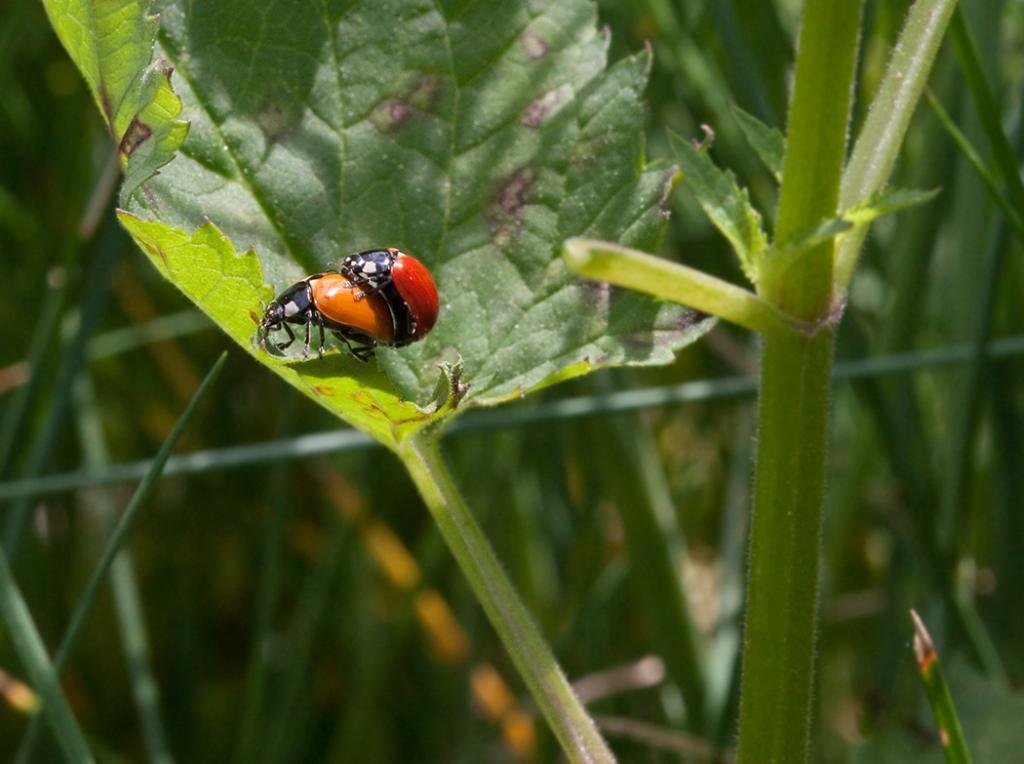Can you describe this image briefly? In this picture I can see there is a insect sitting on the leaf and there are plants in the backdrop. 